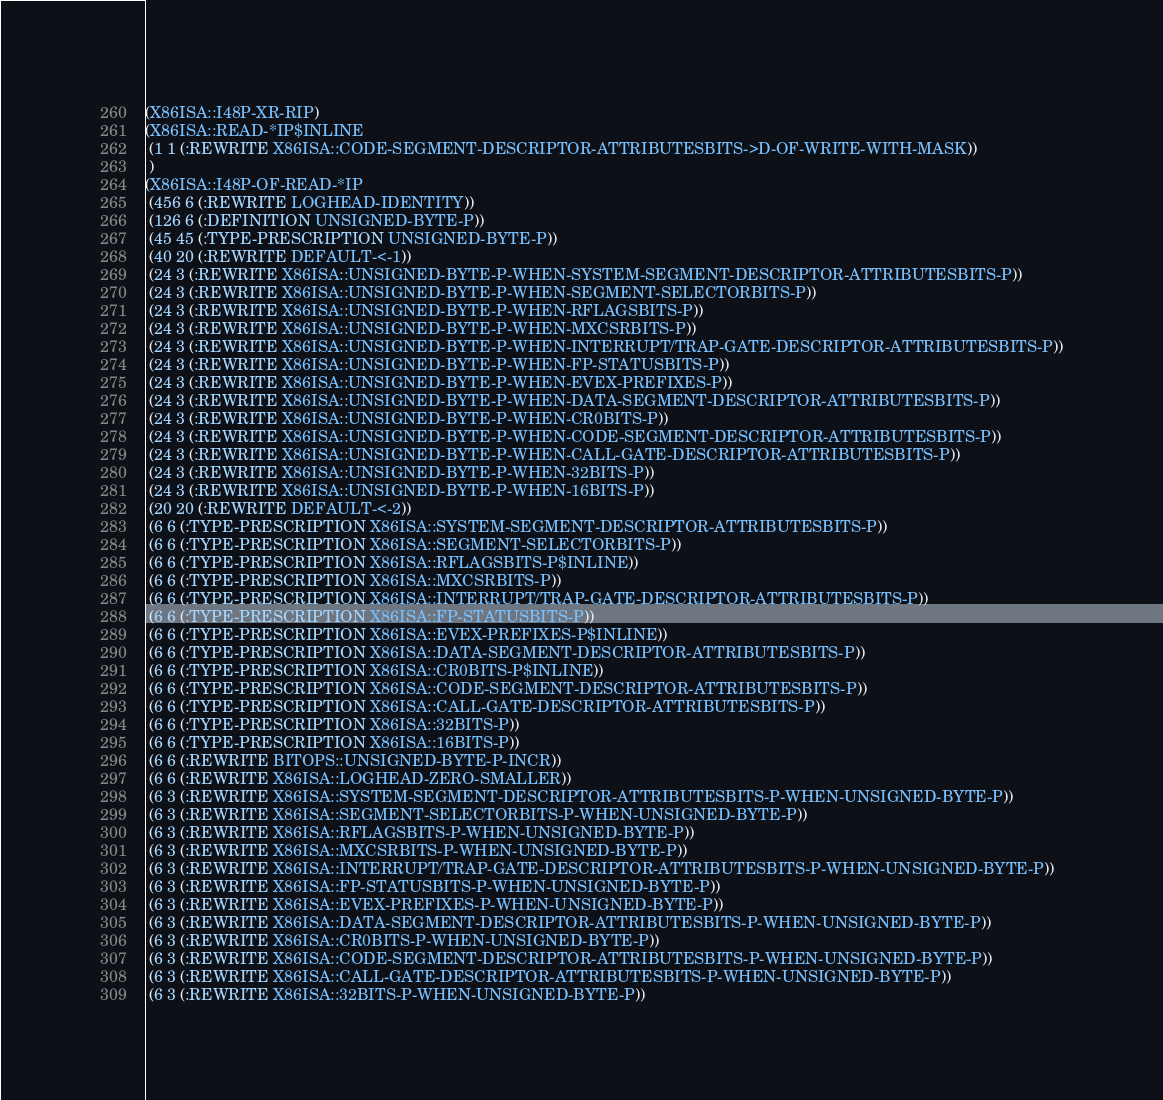<code> <loc_0><loc_0><loc_500><loc_500><_Lisp_>(X86ISA::I48P-XR-RIP)
(X86ISA::READ-*IP$INLINE
 (1 1 (:REWRITE X86ISA::CODE-SEGMENT-DESCRIPTOR-ATTRIBUTESBITS->D-OF-WRITE-WITH-MASK))
 )
(X86ISA::I48P-OF-READ-*IP
 (456 6 (:REWRITE LOGHEAD-IDENTITY))
 (126 6 (:DEFINITION UNSIGNED-BYTE-P))
 (45 45 (:TYPE-PRESCRIPTION UNSIGNED-BYTE-P))
 (40 20 (:REWRITE DEFAULT-<-1))
 (24 3 (:REWRITE X86ISA::UNSIGNED-BYTE-P-WHEN-SYSTEM-SEGMENT-DESCRIPTOR-ATTRIBUTESBITS-P))
 (24 3 (:REWRITE X86ISA::UNSIGNED-BYTE-P-WHEN-SEGMENT-SELECTORBITS-P))
 (24 3 (:REWRITE X86ISA::UNSIGNED-BYTE-P-WHEN-RFLAGSBITS-P))
 (24 3 (:REWRITE X86ISA::UNSIGNED-BYTE-P-WHEN-MXCSRBITS-P))
 (24 3 (:REWRITE X86ISA::UNSIGNED-BYTE-P-WHEN-INTERRUPT/TRAP-GATE-DESCRIPTOR-ATTRIBUTESBITS-P))
 (24 3 (:REWRITE X86ISA::UNSIGNED-BYTE-P-WHEN-FP-STATUSBITS-P))
 (24 3 (:REWRITE X86ISA::UNSIGNED-BYTE-P-WHEN-EVEX-PREFIXES-P))
 (24 3 (:REWRITE X86ISA::UNSIGNED-BYTE-P-WHEN-DATA-SEGMENT-DESCRIPTOR-ATTRIBUTESBITS-P))
 (24 3 (:REWRITE X86ISA::UNSIGNED-BYTE-P-WHEN-CR0BITS-P))
 (24 3 (:REWRITE X86ISA::UNSIGNED-BYTE-P-WHEN-CODE-SEGMENT-DESCRIPTOR-ATTRIBUTESBITS-P))
 (24 3 (:REWRITE X86ISA::UNSIGNED-BYTE-P-WHEN-CALL-GATE-DESCRIPTOR-ATTRIBUTESBITS-P))
 (24 3 (:REWRITE X86ISA::UNSIGNED-BYTE-P-WHEN-32BITS-P))
 (24 3 (:REWRITE X86ISA::UNSIGNED-BYTE-P-WHEN-16BITS-P))
 (20 20 (:REWRITE DEFAULT-<-2))
 (6 6 (:TYPE-PRESCRIPTION X86ISA::SYSTEM-SEGMENT-DESCRIPTOR-ATTRIBUTESBITS-P))
 (6 6 (:TYPE-PRESCRIPTION X86ISA::SEGMENT-SELECTORBITS-P))
 (6 6 (:TYPE-PRESCRIPTION X86ISA::RFLAGSBITS-P$INLINE))
 (6 6 (:TYPE-PRESCRIPTION X86ISA::MXCSRBITS-P))
 (6 6 (:TYPE-PRESCRIPTION X86ISA::INTERRUPT/TRAP-GATE-DESCRIPTOR-ATTRIBUTESBITS-P))
 (6 6 (:TYPE-PRESCRIPTION X86ISA::FP-STATUSBITS-P))
 (6 6 (:TYPE-PRESCRIPTION X86ISA::EVEX-PREFIXES-P$INLINE))
 (6 6 (:TYPE-PRESCRIPTION X86ISA::DATA-SEGMENT-DESCRIPTOR-ATTRIBUTESBITS-P))
 (6 6 (:TYPE-PRESCRIPTION X86ISA::CR0BITS-P$INLINE))
 (6 6 (:TYPE-PRESCRIPTION X86ISA::CODE-SEGMENT-DESCRIPTOR-ATTRIBUTESBITS-P))
 (6 6 (:TYPE-PRESCRIPTION X86ISA::CALL-GATE-DESCRIPTOR-ATTRIBUTESBITS-P))
 (6 6 (:TYPE-PRESCRIPTION X86ISA::32BITS-P))
 (6 6 (:TYPE-PRESCRIPTION X86ISA::16BITS-P))
 (6 6 (:REWRITE BITOPS::UNSIGNED-BYTE-P-INCR))
 (6 6 (:REWRITE X86ISA::LOGHEAD-ZERO-SMALLER))
 (6 3 (:REWRITE X86ISA::SYSTEM-SEGMENT-DESCRIPTOR-ATTRIBUTESBITS-P-WHEN-UNSIGNED-BYTE-P))
 (6 3 (:REWRITE X86ISA::SEGMENT-SELECTORBITS-P-WHEN-UNSIGNED-BYTE-P))
 (6 3 (:REWRITE X86ISA::RFLAGSBITS-P-WHEN-UNSIGNED-BYTE-P))
 (6 3 (:REWRITE X86ISA::MXCSRBITS-P-WHEN-UNSIGNED-BYTE-P))
 (6 3 (:REWRITE X86ISA::INTERRUPT/TRAP-GATE-DESCRIPTOR-ATTRIBUTESBITS-P-WHEN-UNSIGNED-BYTE-P))
 (6 3 (:REWRITE X86ISA::FP-STATUSBITS-P-WHEN-UNSIGNED-BYTE-P))
 (6 3 (:REWRITE X86ISA::EVEX-PREFIXES-P-WHEN-UNSIGNED-BYTE-P))
 (6 3 (:REWRITE X86ISA::DATA-SEGMENT-DESCRIPTOR-ATTRIBUTESBITS-P-WHEN-UNSIGNED-BYTE-P))
 (6 3 (:REWRITE X86ISA::CR0BITS-P-WHEN-UNSIGNED-BYTE-P))
 (6 3 (:REWRITE X86ISA::CODE-SEGMENT-DESCRIPTOR-ATTRIBUTESBITS-P-WHEN-UNSIGNED-BYTE-P))
 (6 3 (:REWRITE X86ISA::CALL-GATE-DESCRIPTOR-ATTRIBUTESBITS-P-WHEN-UNSIGNED-BYTE-P))
 (6 3 (:REWRITE X86ISA::32BITS-P-WHEN-UNSIGNED-BYTE-P))</code> 